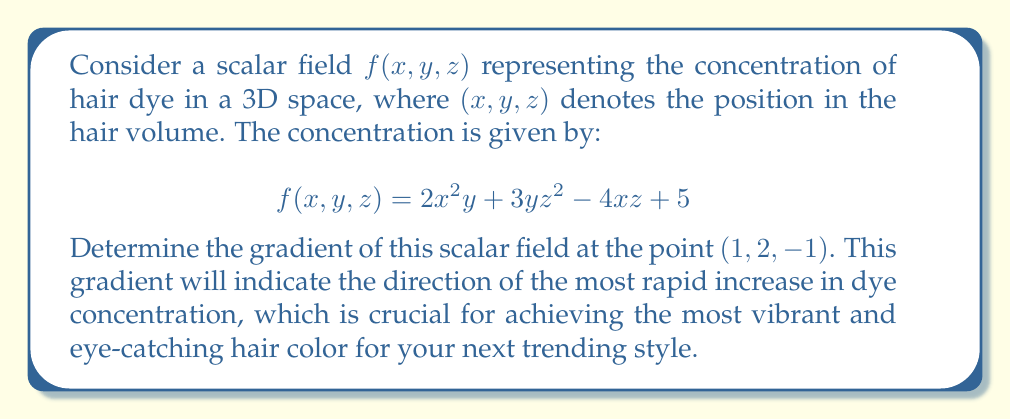Give your solution to this math problem. To find the gradient of the scalar field $f(x, y, z)$, we need to calculate the partial derivatives with respect to each variable and evaluate them at the given point.

Step 1: Calculate the partial derivatives.

$$\frac{\partial f}{\partial x} = 4xy - 4z$$
$$\frac{\partial f}{\partial y} = 2x^2 + 3z^2$$
$$\frac{\partial f}{\partial z} = 6yz - 4x$$

Step 2: The gradient is defined as:

$$\nabla f = \left(\frac{\partial f}{\partial x}, \frac{\partial f}{\partial y}, \frac{\partial f}{\partial z}\right)$$

Step 3: Evaluate the partial derivatives at the point $(1, 2, -1)$.

$$\frac{\partial f}{\partial x}(1, 2, -1) = 4(1)(2) - 4(-1) = 12$$
$$\frac{\partial f}{\partial y}(1, 2, -1) = 2(1)^2 + 3(-1)^2 = 5$$
$$\frac{\partial f}{\partial z}(1, 2, -1) = 6(2)(-1) - 4(1) = -16$$

Step 4: Combine the results to form the gradient vector.

$$\nabla f(1, 2, -1) = (12, 5, -16)$$

This gradient vector indicates that at the point (1, 2, -1), the dye concentration increases most rapidly in the direction of (12, 5, -16).
Answer: $(12, 5, -16)$ 